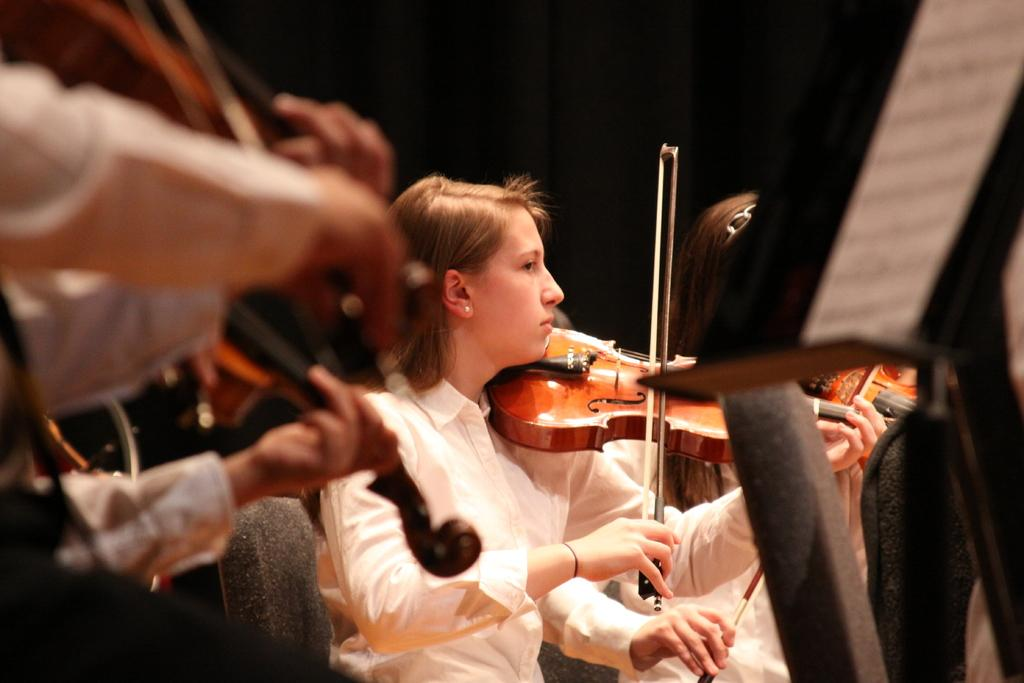What are the people in the image doing? The people in the image are playing violins. What object can be seen in the image that is related to reading or displaying materials? There is a book stand in the image. What is the purpose of the book stand in the image? The book stand is in front of a theme, possibly for the music or performance. Where is the sofa located in the image? There is no sofa present in the image. What type of notebook is being used by the people playing violins in the image? There is no notebook visible in the image; the people are playing violins. 